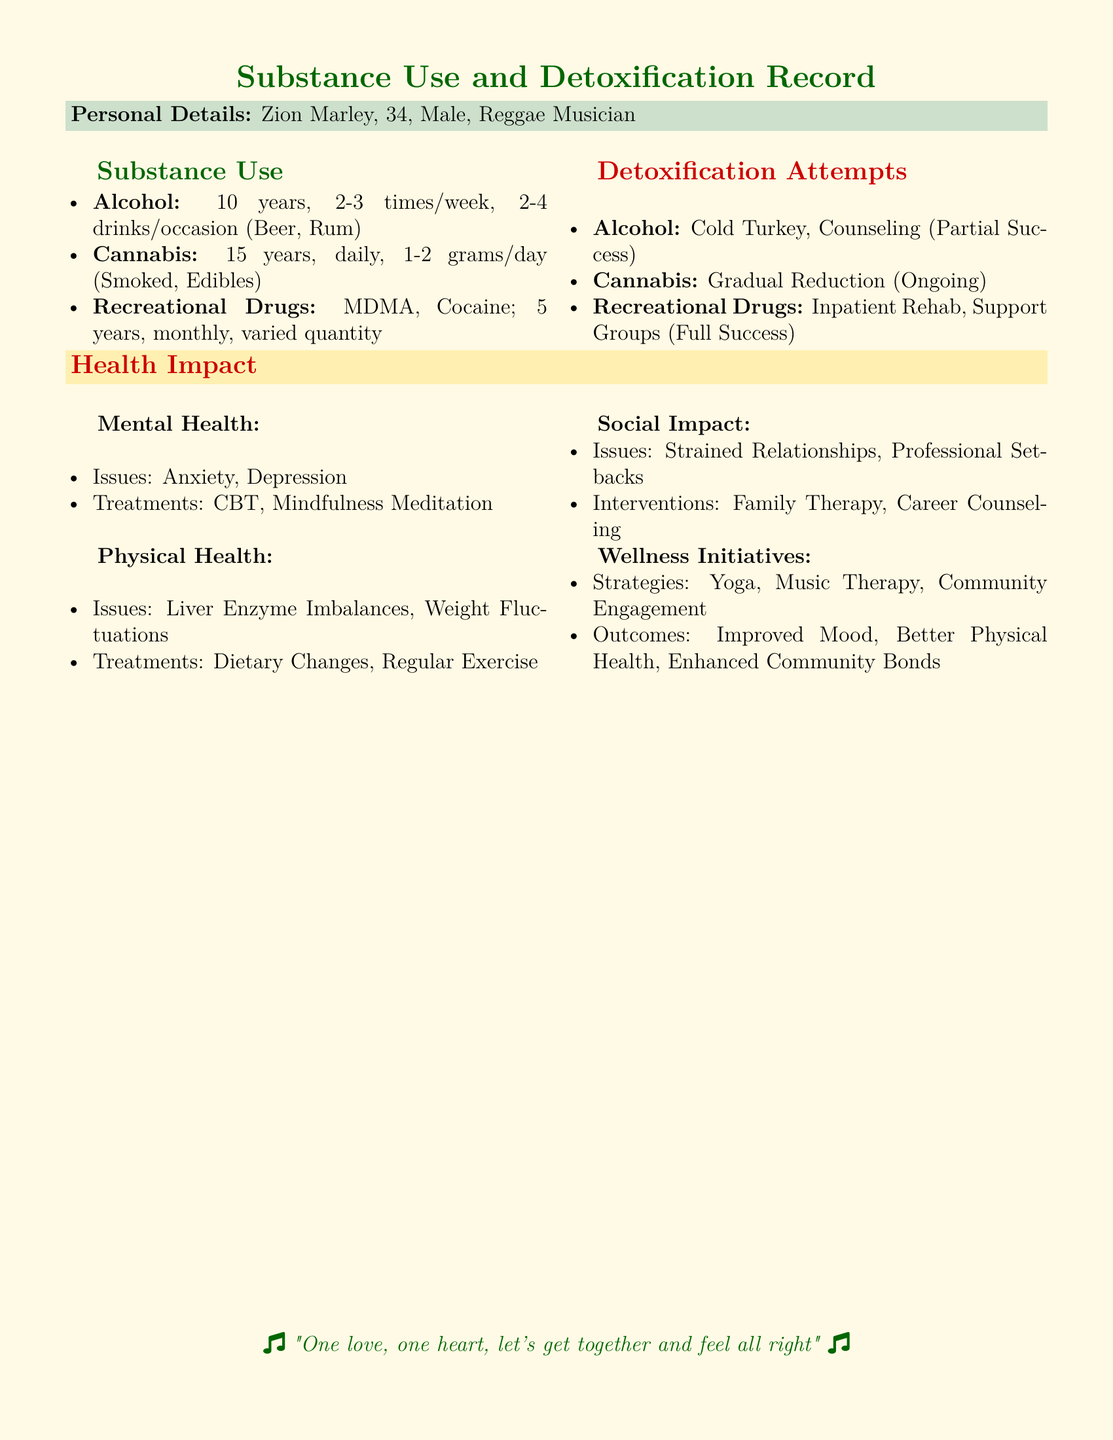What is the patient's name? The name of the patient is clearly stated in the document's personal details.
Answer: Zion Marley How long has the patient been using cannabis? The document specifies the duration of cannabis use under the substance use section.
Answer: 15 years What type of therapy was used for alcohol detoxification? The document outlines the methods employed for detoxification attempts, specifically for alcohol.
Answer: Counseling What were the main mental health issues reported? The document lists the mental health issues experienced by the patient under the health impact section.
Answer: Anxiety, Depression What is the outcome of the inpatient rehab for recreational drugs? The document notes the success level of the detoxification attempt for recreational drugs.
Answer: Full Success What wellness initiative involves physical activity? The document enumerates strategies for wellness initiatives, some of which include physical activity.
Answer: Yoga How frequently does the patient consume alcohol? The document mentions the frequency of alcohol consumption in the substance use section.
Answer: 2-3 times/week Which dietary issue was noted in the physical health section? The document provides information about physical health issues, including one related to dietary concerns.
Answer: Liver Enzyme Imbalances What is the age of the patient? The age of the patient is clearly stated in the personal details.
Answer: 34 What was a documented social impact of substance use? The document highlights social issues related to substance use in the health impact section.
Answer: Strained Relationships 